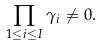Convert formula to latex. <formula><loc_0><loc_0><loc_500><loc_500>\prod _ { 1 \leq i \leq I } \gamma _ { i } \neq 0 .</formula> 